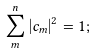Convert formula to latex. <formula><loc_0><loc_0><loc_500><loc_500>\sum _ { m } ^ { n } | c _ { m } | ^ { 2 } = 1 ;</formula> 